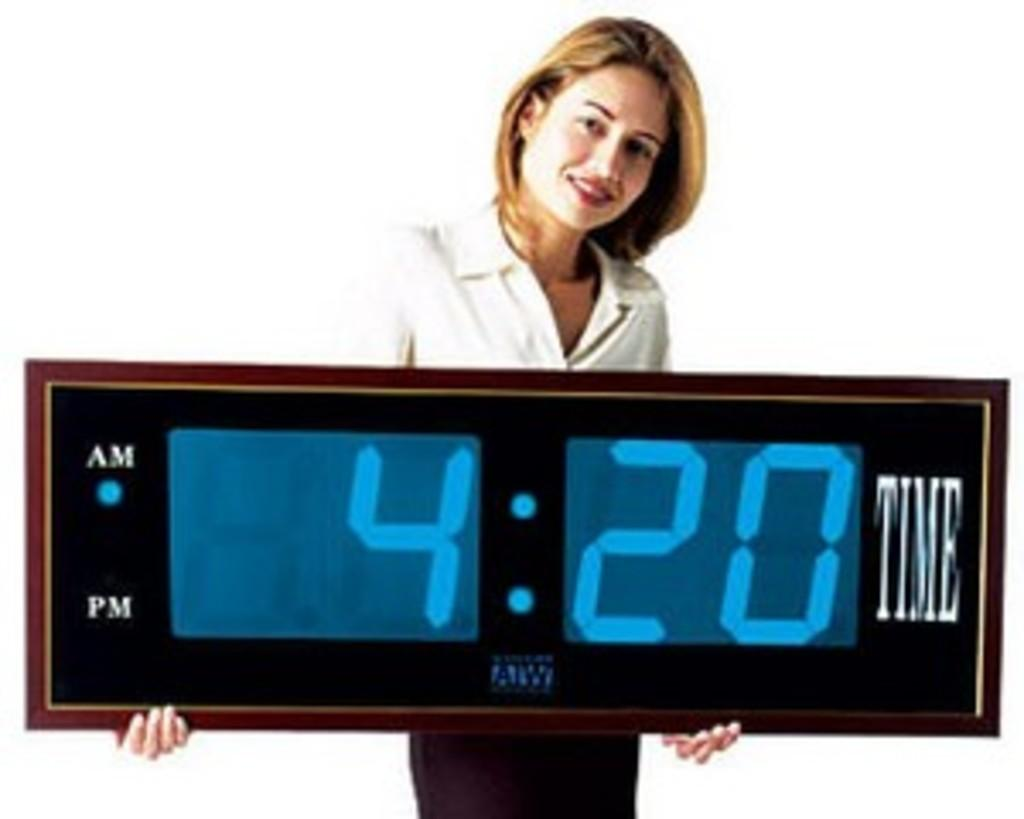<image>
Create a compact narrative representing the image presented. the time on the clock says 4:20 as the lady holds it 